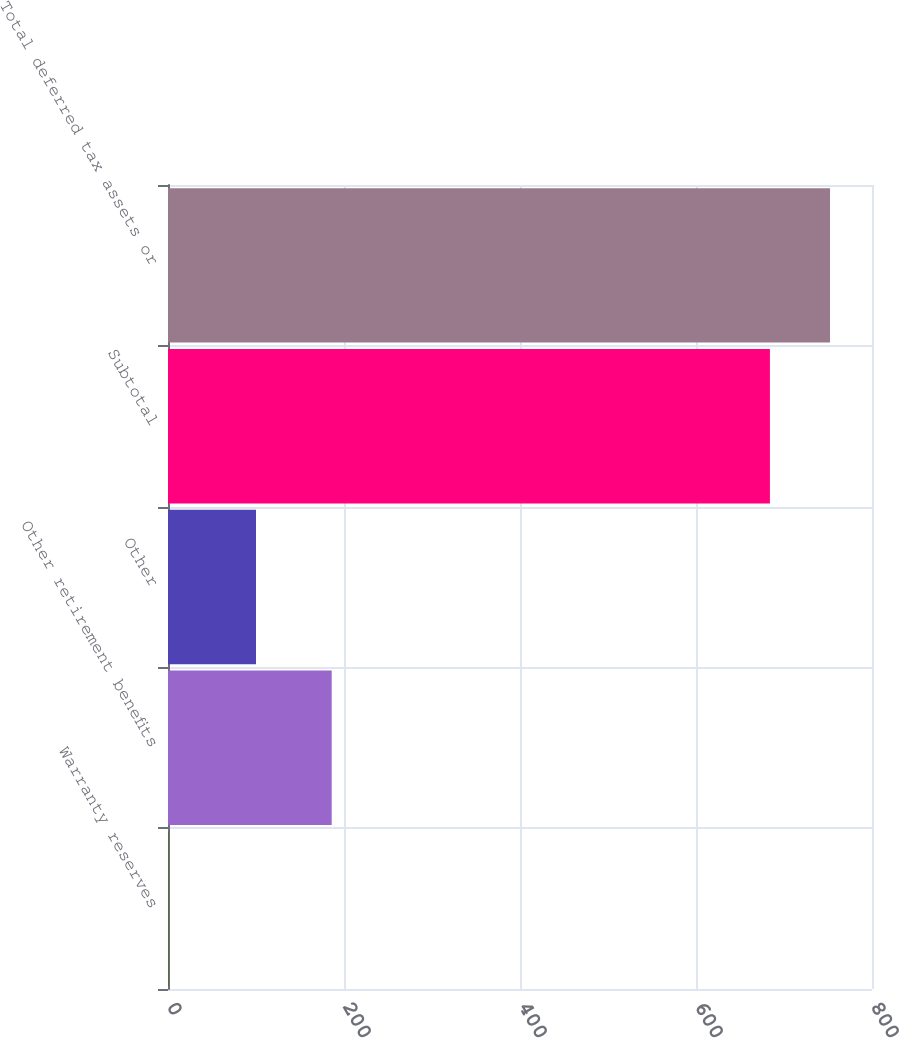Convert chart to OTSL. <chart><loc_0><loc_0><loc_500><loc_500><bar_chart><fcel>Warranty reserves<fcel>Other retirement benefits<fcel>Other<fcel>Subtotal<fcel>Total deferred tax assets or<nl><fcel>1<fcel>186<fcel>100<fcel>684<fcel>752.3<nl></chart> 